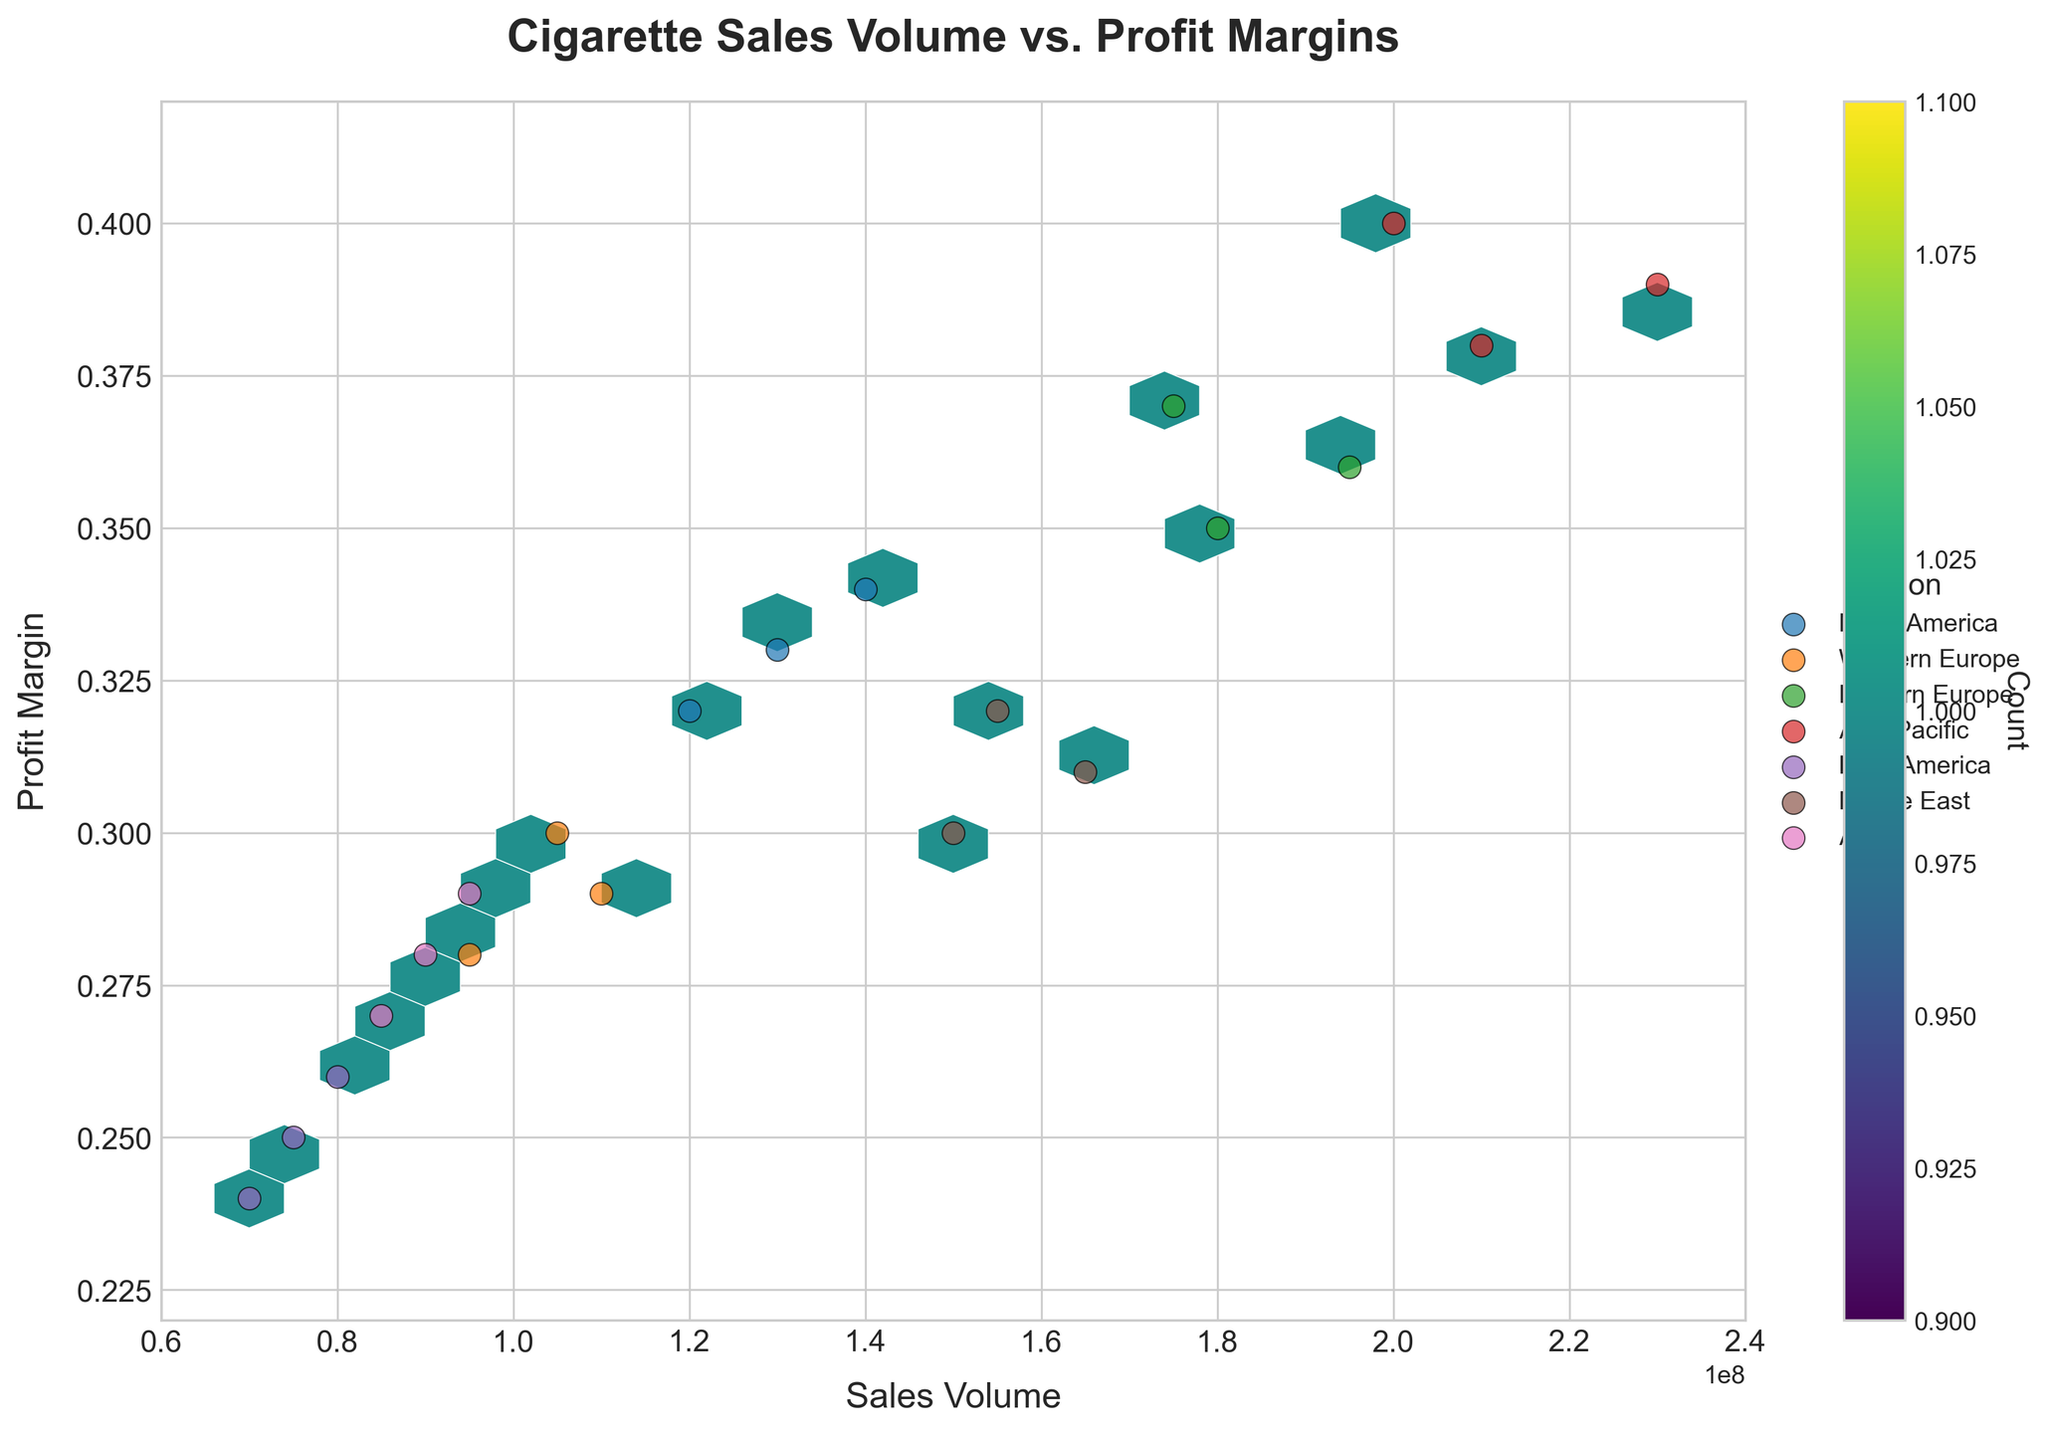What is the title of the plot? The title is located at the top of the plot and is usually in a larger and bold font to help summarize the main content of the plot. The title given here is "Cigarette Sales Volume vs. Profit Margins".
Answer: Cigarette Sales Volume vs. Profit Margins What are the labels of the x-axis and y-axis? The labels for the axes describe what each axis represents. In this plot, the x-axis represents "Sales Volume" and the y-axis represents "Profit Margin".
Answer: Sales Volume, Profit Margin How many data points are represented in the highest density hexagon? To determine this, refer to the color bar which translates colors to counts. The hexbin with the darkest color corresponds to the highest count, which from the color bar can be identified.
Answer: 3 What range of Sales Volume and Profit Margin does the plot cover? The range of Sales Volume can be read from the x-axis and the range of Profit Margin from the y-axis. The x-axis ranges from 60,000,000 to 240,000,000 and the y-axis ranges from 0.22 to 0.42.
Answer: 60,000,000 to 240,000,000, 0.22 to 0.42 Which region appears to have the highest profit margin, and what is that value? Scattered points for different regions are colored and labeled differently. By identifying the highest point on the y-axis, we can determine the region and its associated Profit Margin. The highest Profit Margin is for Asia Pacific at 0.40.
Answer: Asia Pacific, 0.40 Which regions have overlapping data points within the same hexagon? Overlapping points in the same hexagon are often indicated by the overall density. By examining the legend and the scatter points in the plot, we notice multiple regions such as Africa and Latin America having overlapping hexagons.
Answer: Africa, Latin America How does the average Sales Volume of the Asia Pacific region compare to that of Western Europe? Calculate the average Sales Volume for each region by summing the volumes and dividing by the count of data points for each. Asia Pacific has volumes of 210,000,000, 230,000,000, and 200,000,000; the average is (210,000,000 + 230,000,000 + 200,000,000) / 3. Western Europe has volumes of 95,000,000, 110,000,000, and 105,000,000; the average is (95,000,000 + 110,000,000 + 105,000,000) / 3.
Answer: Asia Pacific average is 213,333,333.3, Western Europe average is 103,333,333.3 What can you infer about the relationship between Sales Volume and Profit Margin from the hexbin pattern? In a hexbin plot, the density and overall spread of hexagon bins indicate the relationship. There appears to be a positive correlation where higher sales volumes tend to be associated with higher profit margins.
Answer: Positive correlation Which region exhibits a wider spread in Sales Volumes? By examining the scatter plot and the spread of points labeled by different colors, the region with the widest spread can be identified. North America has Sales Volumes ranging between 120,000,000 and 140,000,000.
Answer: North America What is the range of Profit Margins for the Middle East region? Checking the scattered points for the Middle East, we can identify the specific y-values. The Middle East has Profit Margins of 0.30, 0.31, and 0.32.
Answer: 0.30 to 0.32 